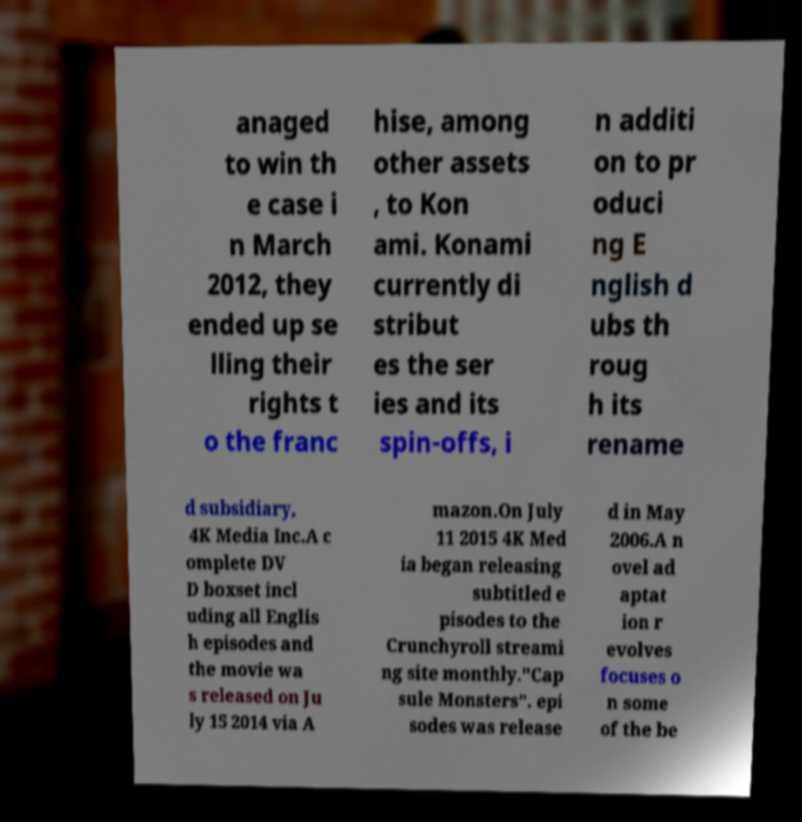Could you assist in decoding the text presented in this image and type it out clearly? anaged to win th e case i n March 2012, they ended up se lling their rights t o the franc hise, among other assets , to Kon ami. Konami currently di stribut es the ser ies and its spin-offs, i n additi on to pr oduci ng E nglish d ubs th roug h its rename d subsidiary, 4K Media Inc.A c omplete DV D boxset incl uding all Englis h episodes and the movie wa s released on Ju ly 15 2014 via A mazon.On July 11 2015 4K Med ia began releasing subtitled e pisodes to the Crunchyroll streami ng site monthly."Cap sule Monsters". epi sodes was release d in May 2006.A n ovel ad aptat ion r evolves focuses o n some of the be 